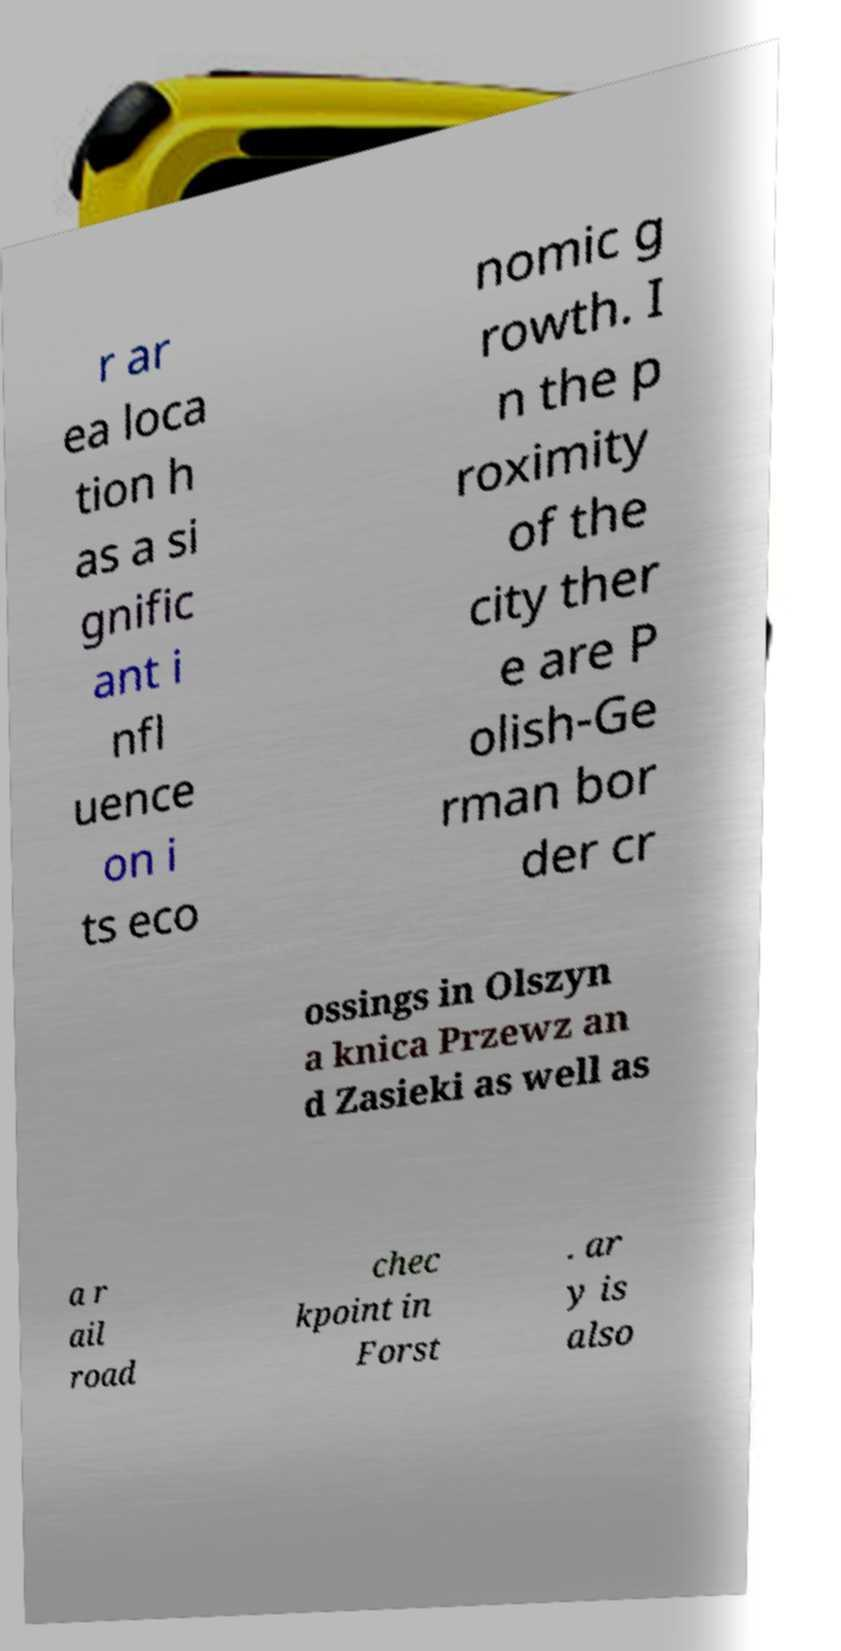Please identify and transcribe the text found in this image. r ar ea loca tion h as a si gnific ant i nfl uence on i ts eco nomic g rowth. I n the p roximity of the city ther e are P olish-Ge rman bor der cr ossings in Olszyn a knica Przewz an d Zasieki as well as a r ail road chec kpoint in Forst . ar y is also 